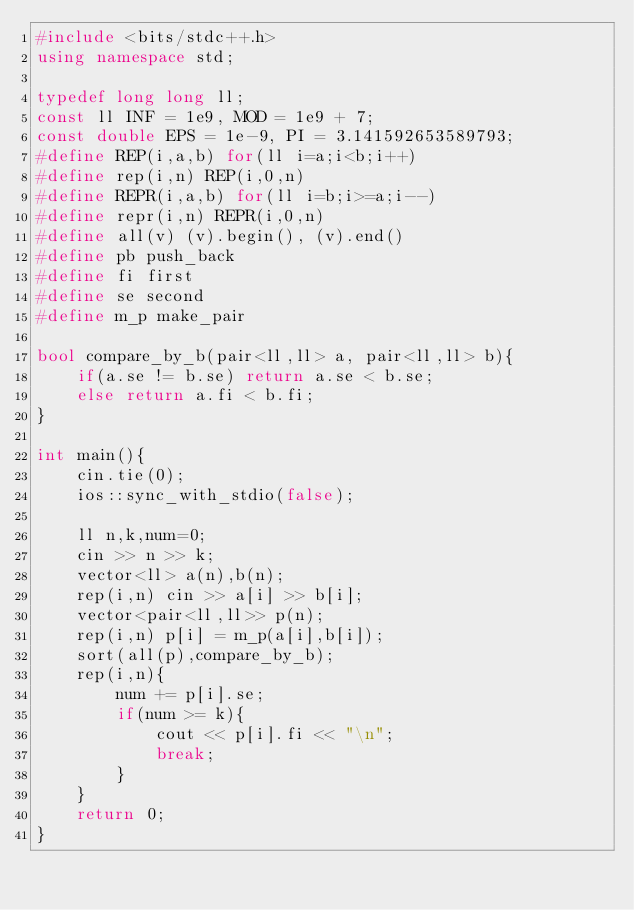Convert code to text. <code><loc_0><loc_0><loc_500><loc_500><_C++_>#include <bits/stdc++.h>
using namespace std;

typedef long long ll;
const ll INF = 1e9, MOD = 1e9 + 7;
const double EPS = 1e-9, PI = 3.141592653589793;
#define REP(i,a,b) for(ll i=a;i<b;i++)
#define rep(i,n) REP(i,0,n)
#define REPR(i,a,b) for(ll i=b;i>=a;i--)
#define repr(i,n) REPR(i,0,n)
#define all(v) (v).begin(), (v).end()
#define pb push_back
#define fi first
#define se second
#define m_p make_pair

bool compare_by_b(pair<ll,ll> a, pair<ll,ll> b){
    if(a.se != b.se) return a.se < b.se;
    else return a.fi < b.fi;
}

int main(){
    cin.tie(0);
    ios::sync_with_stdio(false);

    ll n,k,num=0;
    cin >> n >> k;
    vector<ll> a(n),b(n);
    rep(i,n) cin >> a[i] >> b[i];
    vector<pair<ll,ll>> p(n);
    rep(i,n) p[i] = m_p(a[i],b[i]);
    sort(all(p),compare_by_b);
    rep(i,n){
        num += p[i].se;
        if(num >= k){
            cout << p[i].fi << "\n";
            break;
        }
    }
    return 0;
}</code> 